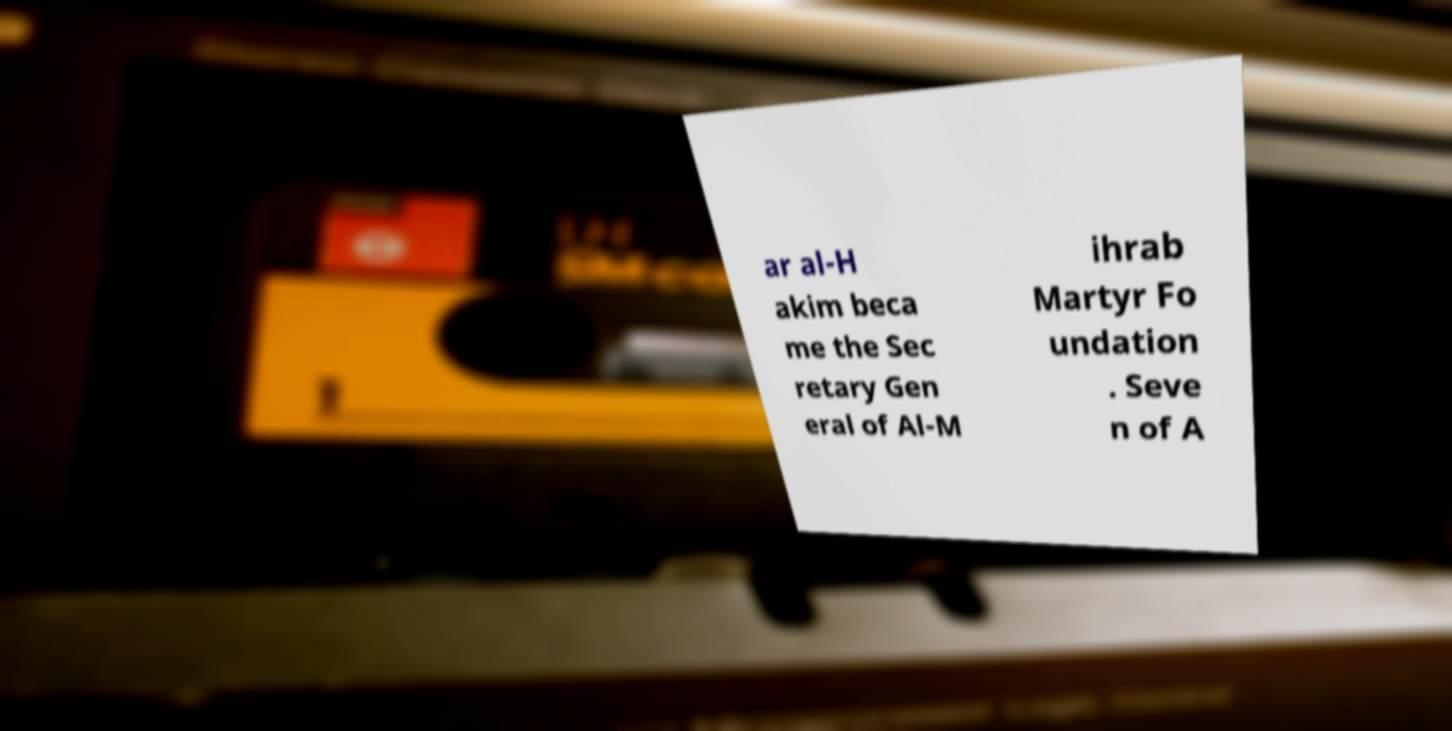There's text embedded in this image that I need extracted. Can you transcribe it verbatim? ar al-H akim beca me the Sec retary Gen eral of Al-M ihrab Martyr Fo undation . Seve n of A 